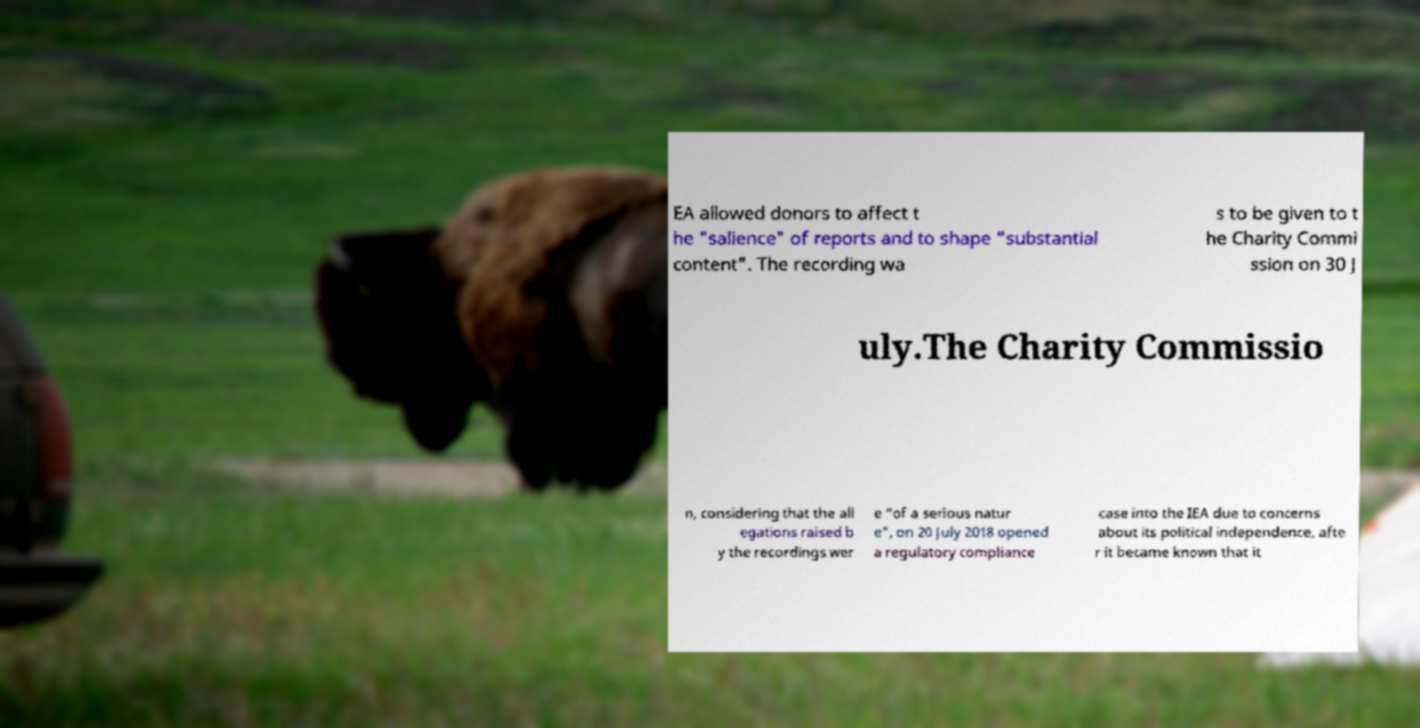Can you accurately transcribe the text from the provided image for me? EA allowed donors to affect t he "salience" of reports and to shape "substantial content". The recording wa s to be given to t he Charity Commi ssion on 30 J uly.The Charity Commissio n, considering that the all egations raised b y the recordings wer e "of a serious natur e", on 20 July 2018 opened a regulatory compliance case into the IEA due to concerns about its political independence, afte r it became known that it 